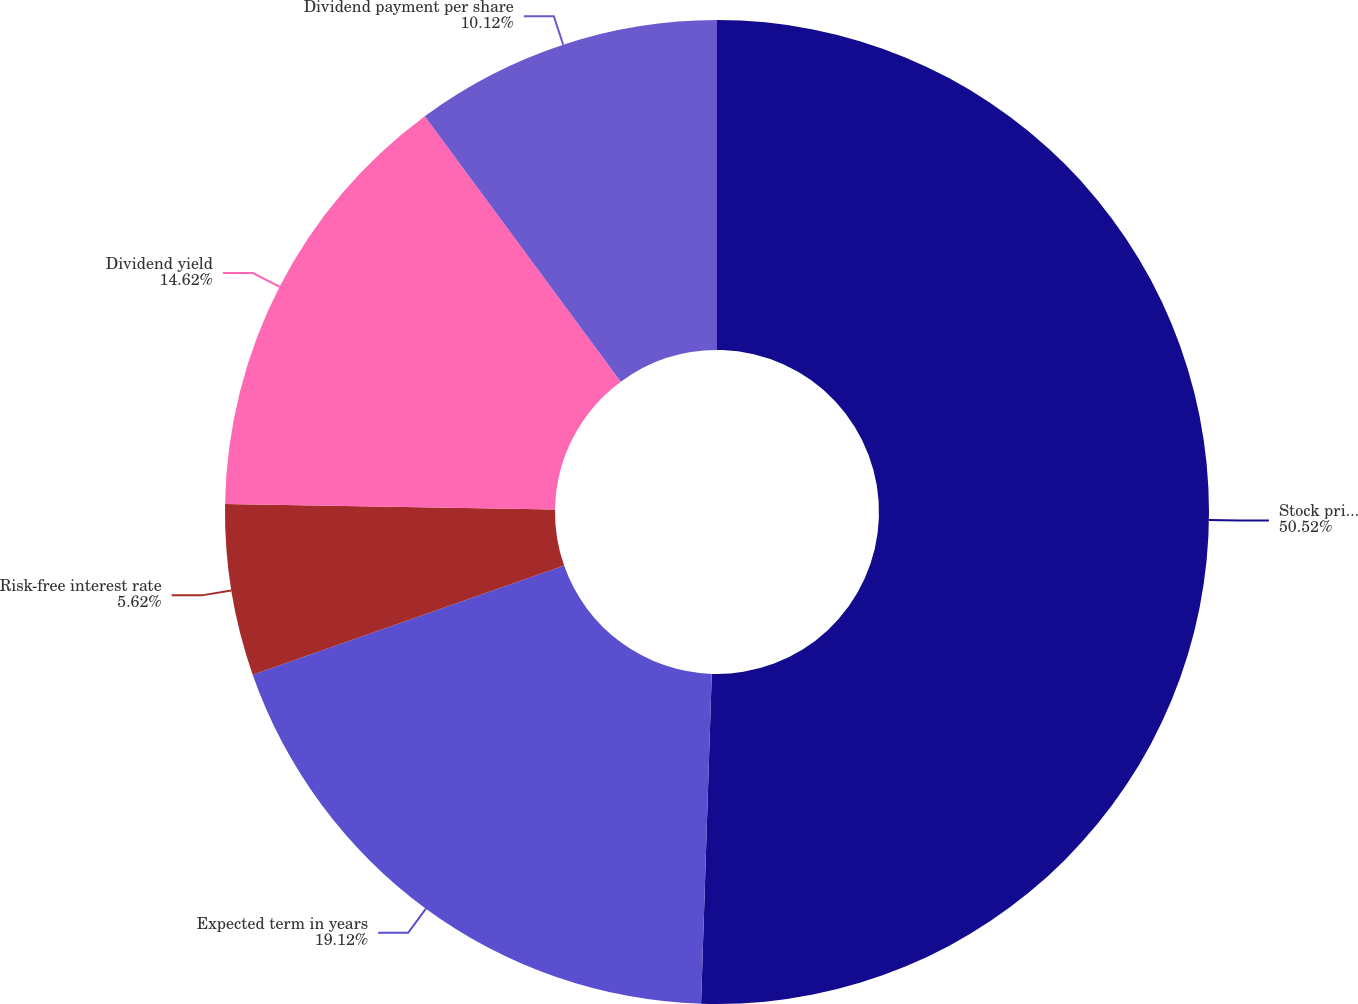Convert chart. <chart><loc_0><loc_0><loc_500><loc_500><pie_chart><fcel>Stock price volatility<fcel>Expected term in years<fcel>Risk-free interest rate<fcel>Dividend yield<fcel>Dividend payment per share<nl><fcel>50.51%<fcel>19.12%<fcel>5.62%<fcel>14.62%<fcel>10.12%<nl></chart> 